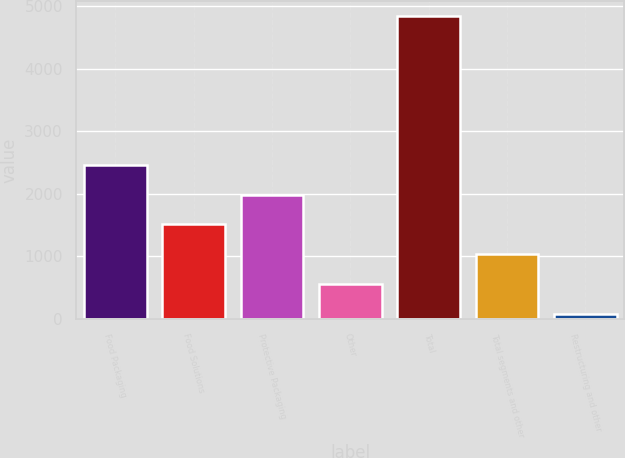Convert chart to OTSL. <chart><loc_0><loc_0><loc_500><loc_500><bar_chart><fcel>Food Packaging<fcel>Food Solutions<fcel>Protective Packaging<fcel>Other<fcel>Total<fcel>Total segments and other<fcel>Restructuring and other<nl><fcel>2464.3<fcel>1512.62<fcel>1988.46<fcel>560.94<fcel>4843.5<fcel>1036.78<fcel>85.1<nl></chart> 